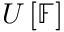Convert formula to latex. <formula><loc_0><loc_0><loc_500><loc_500>U \left [ \mathbb { F } \right ]</formula> 